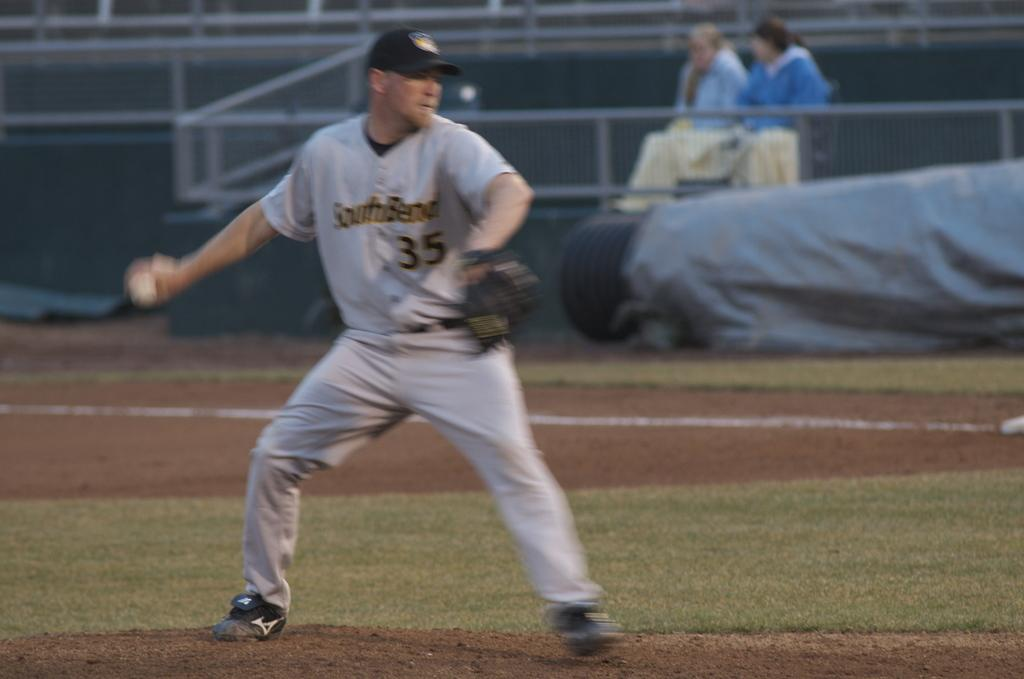Provide a one-sentence caption for the provided image. A player for the South Bend baseball team wears number 35. 